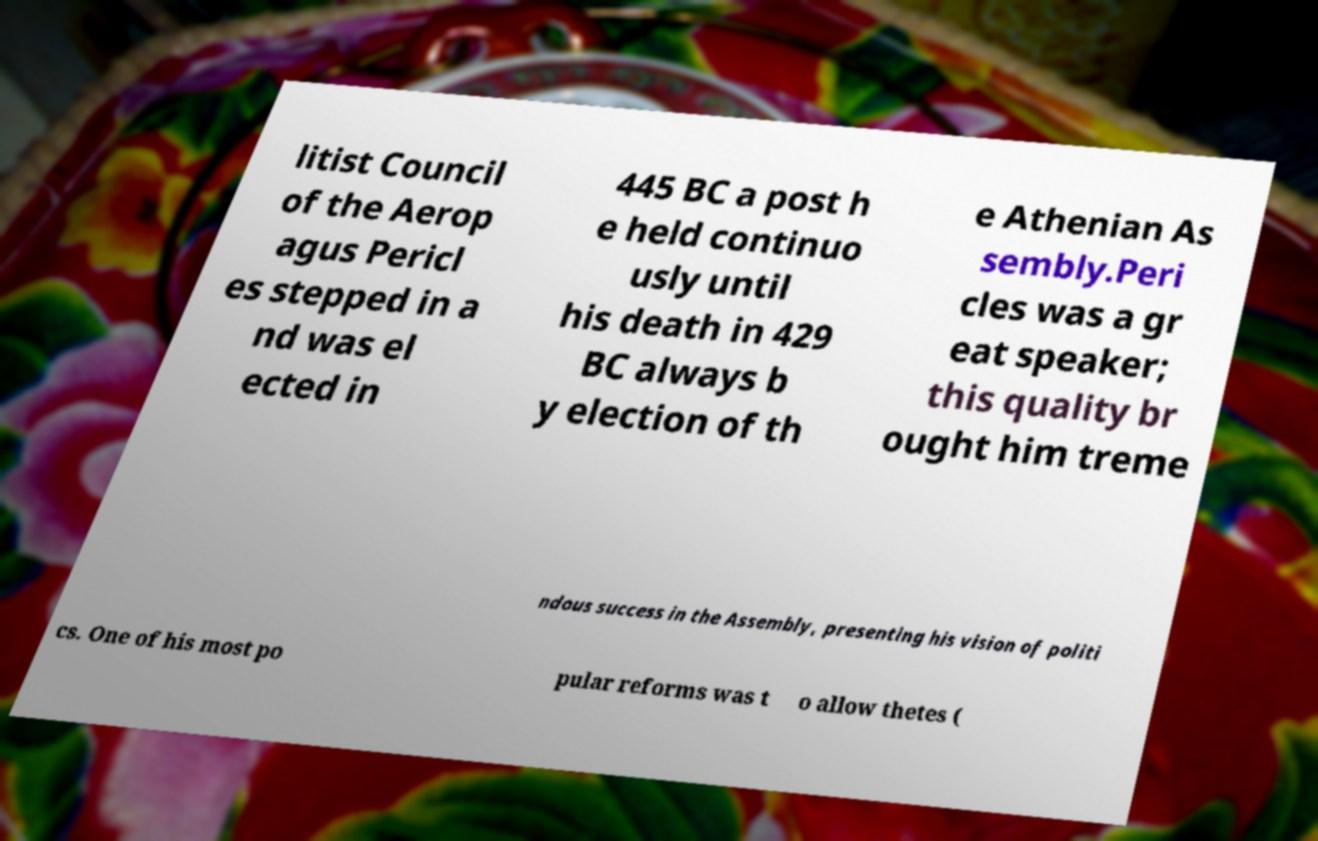I need the written content from this picture converted into text. Can you do that? litist Council of the Aerop agus Pericl es stepped in a nd was el ected in 445 BC a post h e held continuo usly until his death in 429 BC always b y election of th e Athenian As sembly.Peri cles was a gr eat speaker; this quality br ought him treme ndous success in the Assembly, presenting his vision of politi cs. One of his most po pular reforms was t o allow thetes ( 